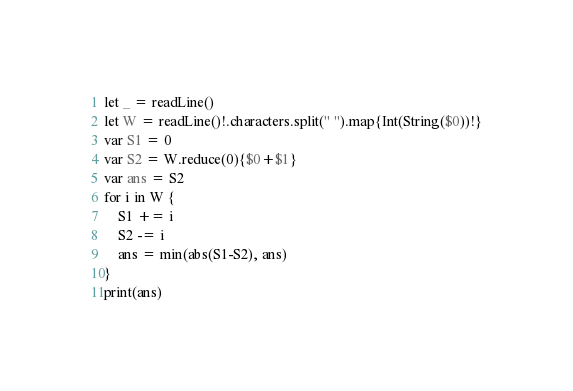<code> <loc_0><loc_0><loc_500><loc_500><_Swift_>let _ = readLine()
let W = readLine()!.characters.split(" ").map{Int(String($0))!}
var S1 = 0
var S2 = W.reduce(0){$0+$1}
var ans = S2
for i in W {
    S1 += i
    S2 -= i
    ans = min(abs(S1-S2), ans)
}
print(ans)</code> 